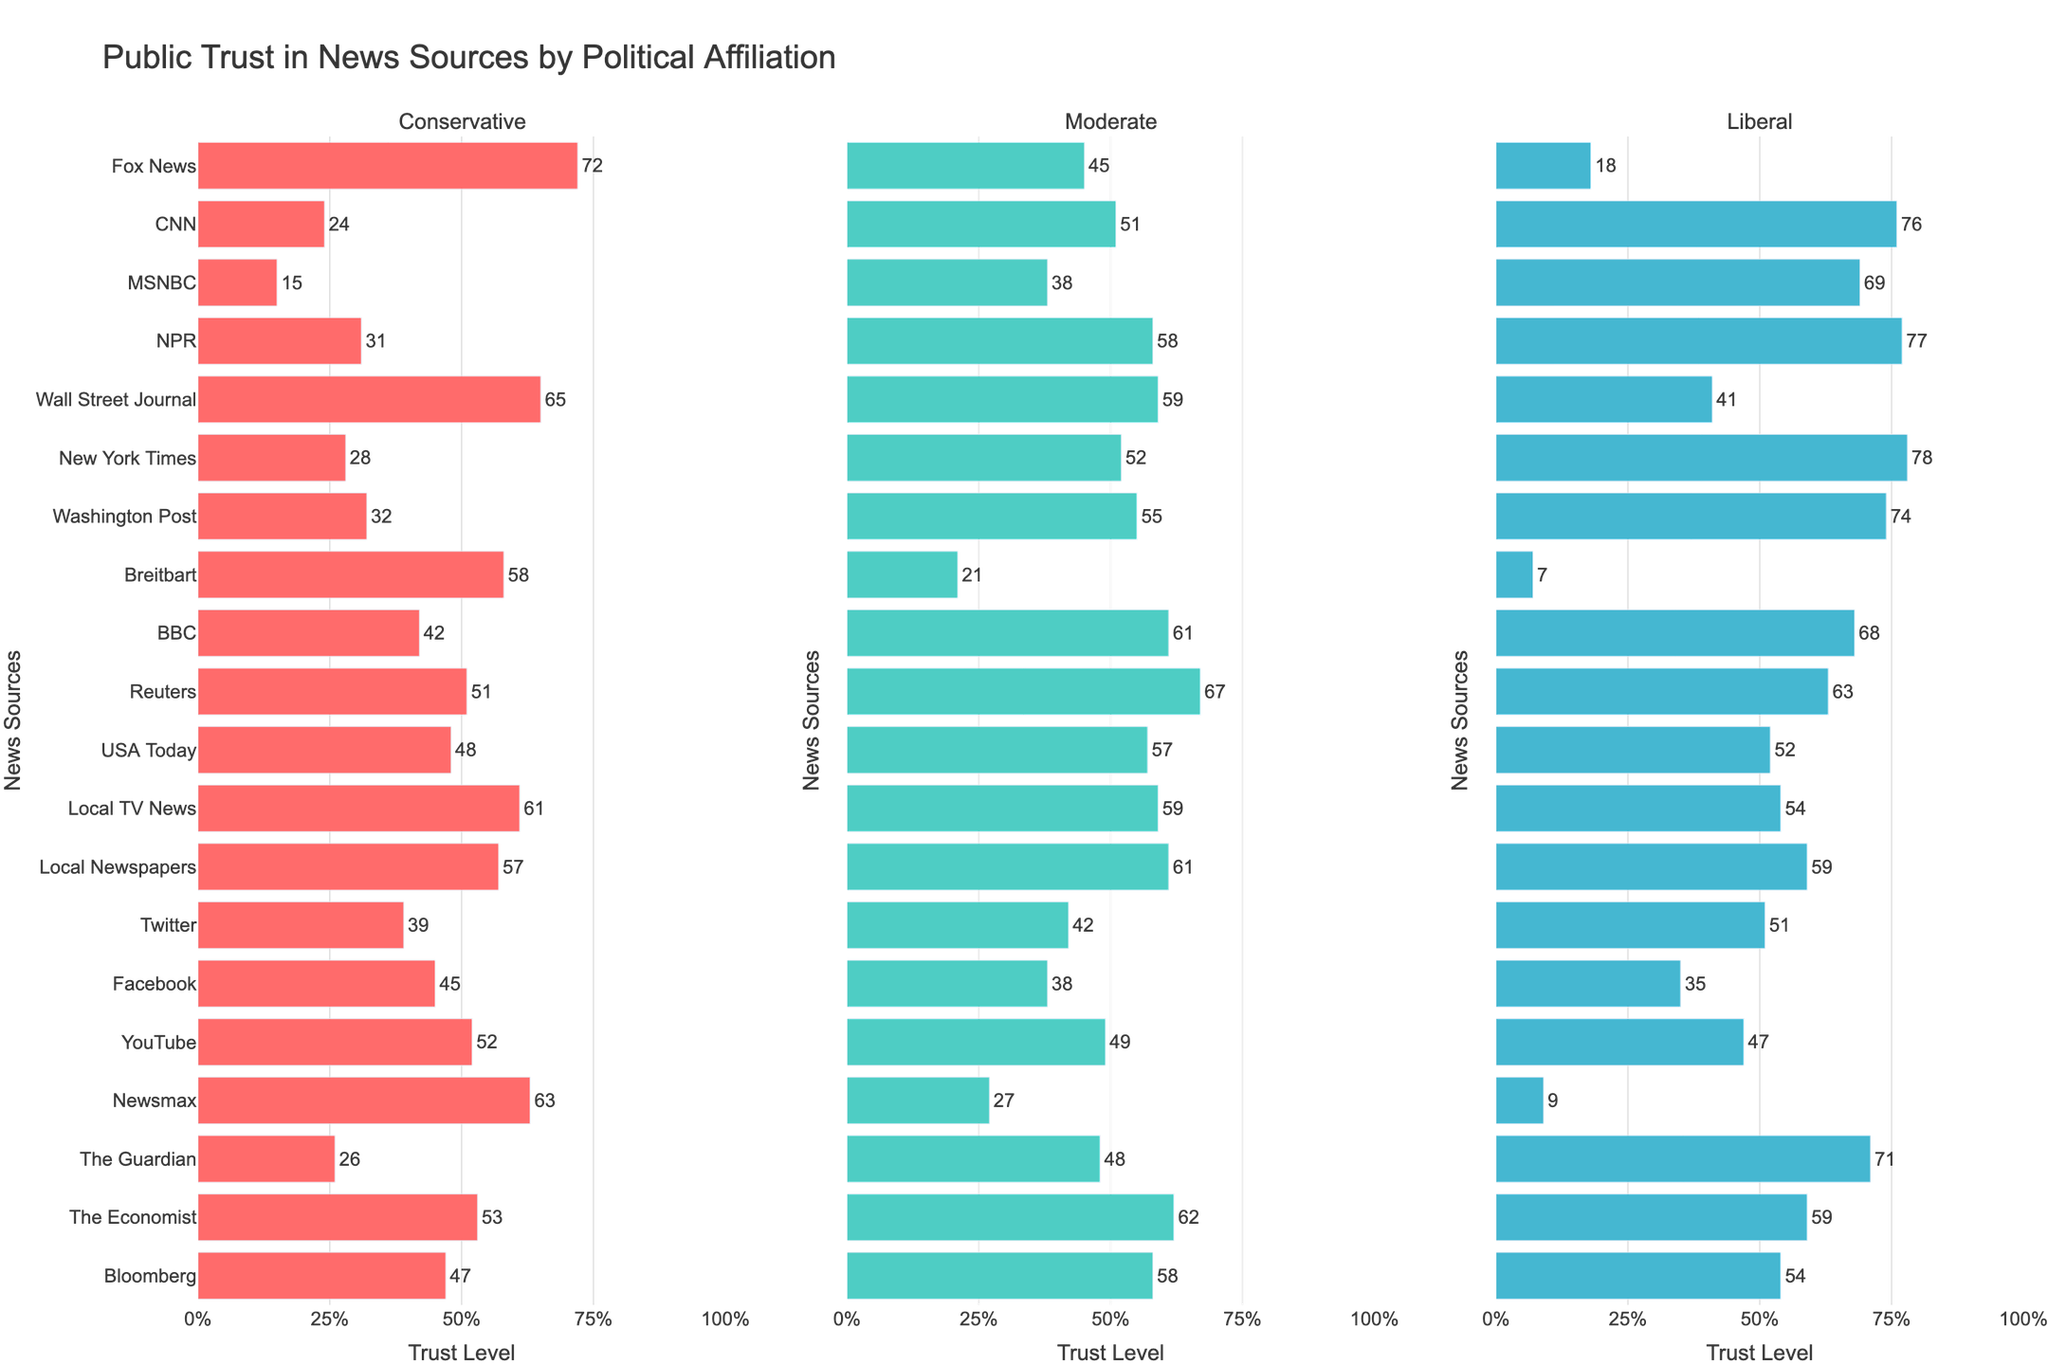Which news source has the highest trust level among liberals? Look at the liberal column and identify the news source with the highest bar: NPR, Fox News, BBC, Reuters, and The Economist have higher values, but New York Times has the highest at 78.
Answer: New York Times Which news source is most trusted by conservatives but least trusted by liberals? Find the news source with the highest trust level in the conservative column and the lowest in the liberal column. Fox News has the highest value (72) in the conservative column and a low (18) in the liberal column.
Answer: Fox News What is the difference in trust level for CNN between conservatives and liberals? Locate CNN's trust levels: 24 for conservatives and 76 for liberals. The difference is 76 - 24.
Answer: 52 Do moderates trust NPR more than conservatives trust Fox News? Compare the trust levels of NPR among moderates (58) and Fox News among conservatives (72). 58 is less than 72.
Answer: No Which has a higher average trust level among all three political affiliations, BBC or Reuters? Calculate the average for each: BBC (42 + 61 + 68)/3 = 171/3 = 57; Reuters (51 + 67 + 63)/3 = 181/3 ≈ 60.33.
Answer: Reuters What are the three least trusted news sources by conservatives? Identify the three smallest values in the conservative column: MSNBC (15), CNN (24), and The Guardian (26).
Answer: MSNBC, CNN, The Guardian Which news source shows the most consistent trust levels across all three political affiliations? Look for similar values across columns for one source. Local Newspapers has close values: Conservative (57), Moderate (61), Liberal (59).
Answer: Local Newspapers What is the total trust level for The Economist across all political affiliations? Add the values for The Economist: 53 (Conservative) + 62 (Moderate) + 59 (Liberal). 53 + 62 + 59 = 174.
Answer: 174 Which political group shows the highest trust in YouTube? Compare YouTube's trust levels across columns: Conservative (52), Moderate (49), and Liberal (47). Conservatives have the highest value.
Answer: Conservatives 